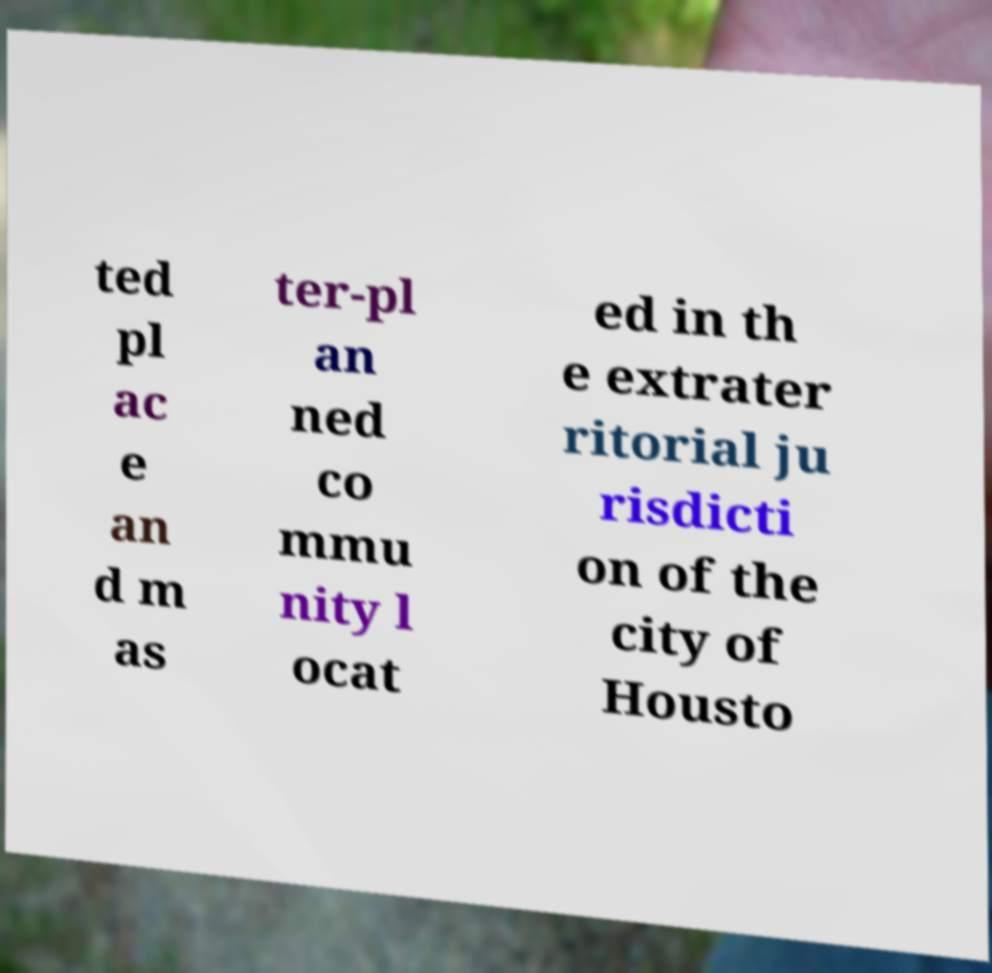Can you accurately transcribe the text from the provided image for me? ted pl ac e an d m as ter-pl an ned co mmu nity l ocat ed in th e extrater ritorial ju risdicti on of the city of Housto 